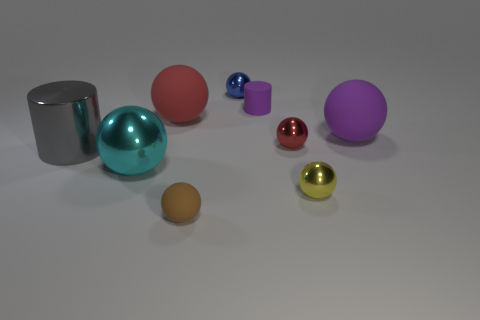How many metal balls are on the right side of the big rubber ball behind the large purple thing?
Your answer should be very brief. 3. How many cubes are tiny blue shiny objects or large red rubber things?
Ensure brevity in your answer.  0. What color is the sphere that is behind the big cyan metal sphere and left of the small brown rubber object?
Provide a short and direct response. Red. Is there anything else of the same color as the small rubber ball?
Keep it short and to the point. No. The small rubber thing behind the big rubber sphere that is on the right side of the tiny blue shiny ball is what color?
Your answer should be compact. Purple. Do the metallic cylinder and the brown object have the same size?
Make the answer very short. No. Are the gray thing in front of the small cylinder and the purple thing that is in front of the purple matte cylinder made of the same material?
Your answer should be compact. No. What is the shape of the rubber thing that is to the right of the matte thing that is behind the big red ball that is left of the tiny brown matte thing?
Keep it short and to the point. Sphere. Are there more objects than purple objects?
Your response must be concise. Yes. Is there a purple sphere?
Your answer should be very brief. Yes. 